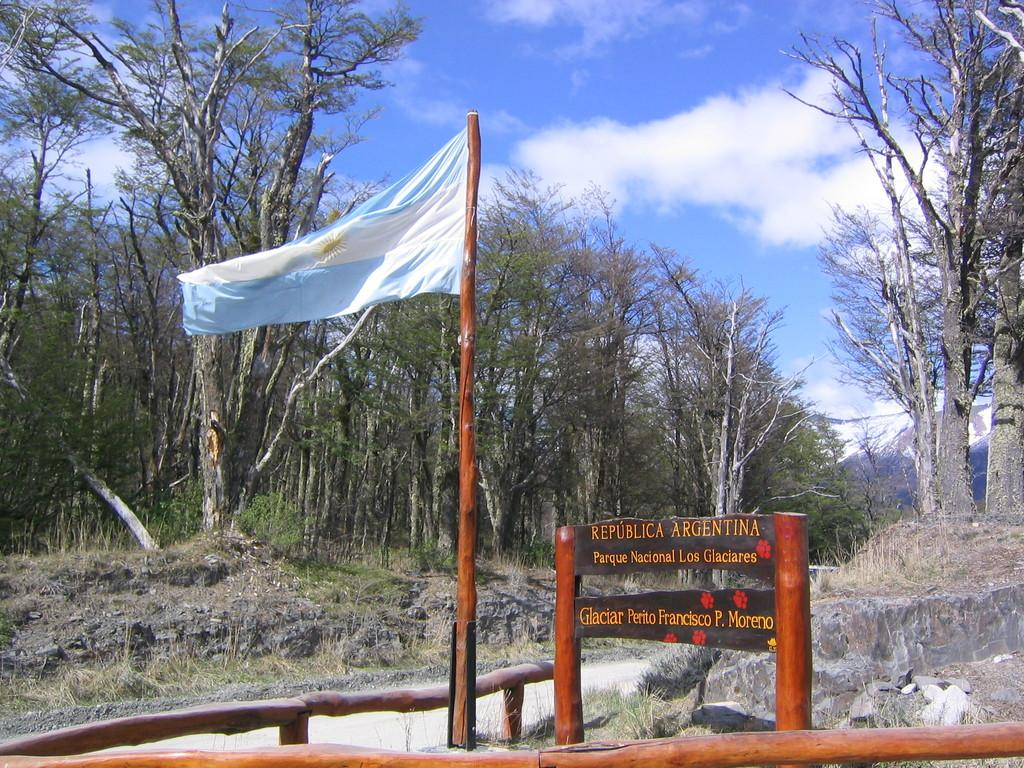What can be seen flying or waving in the image? There is a flag in the image. What is written or displayed on a flat surface in the image? There is a board with text in the image. What type of natural objects can be seen in the image? There are rocks and trees in the image. What structure might provide support or safety in the image? There is a railing in the image. What is visible in the background of the image? The sky is visible in the image. How many flags are present in the image? There is only one flag visible in the image. How many eggs are being carried by the duck in the image? There is no duck or eggs present in the image. What type of insects can be seen crawling on the rocks in the image? There are no insects, including ants, visible in the image. 